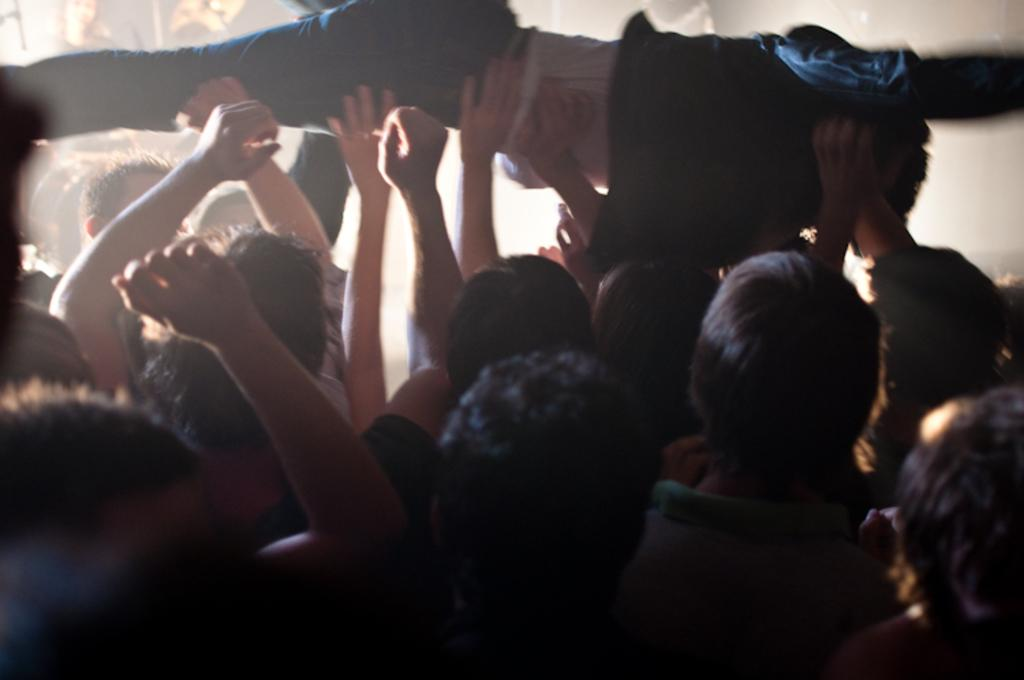How many people are in the image? There are persons in the image, but the exact number is not specified. What are the persons in the image doing? The persons are lifting a guy. Where is the guy being lifted located in the image? The guy being lifted is in the center of the image. What type of canvas is visible in the image? There is no canvas present in the image. What color is the stick being used by the persons in the image? There is no stick visible in the image. 